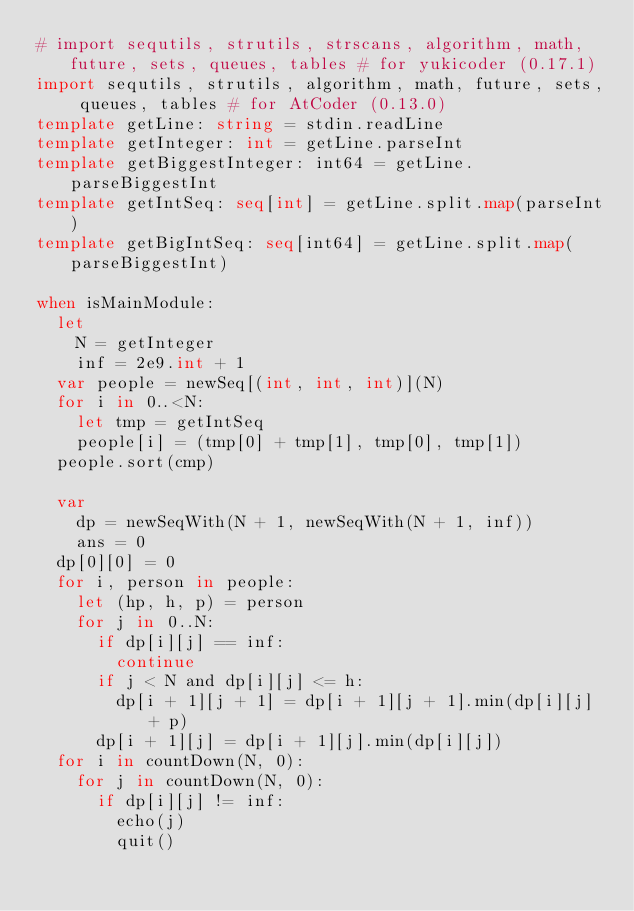Convert code to text. <code><loc_0><loc_0><loc_500><loc_500><_Nim_># import sequtils, strutils, strscans, algorithm, math, future, sets, queues, tables # for yukicoder (0.17.1)
import sequtils, strutils, algorithm, math, future, sets, queues, tables # for AtCoder (0.13.0)
template getLine: string = stdin.readLine
template getInteger: int = getLine.parseInt
template getBiggestInteger: int64 = getLine.parseBiggestInt
template getIntSeq: seq[int] = getLine.split.map(parseInt)
template getBigIntSeq: seq[int64] = getLine.split.map(parseBiggestInt)

when isMainModule:
  let
    N = getInteger
    inf = 2e9.int + 1
  var people = newSeq[(int, int, int)](N)
  for i in 0..<N:
    let tmp = getIntSeq
    people[i] = (tmp[0] + tmp[1], tmp[0], tmp[1])
  people.sort(cmp)

  var
    dp = newSeqWith(N + 1, newSeqWith(N + 1, inf))
    ans = 0
  dp[0][0] = 0
  for i, person in people:
    let (hp, h, p) = person
    for j in 0..N:
      if dp[i][j] == inf:
        continue
      if j < N and dp[i][j] <= h:
        dp[i + 1][j + 1] = dp[i + 1][j + 1].min(dp[i][j] + p)
      dp[i + 1][j] = dp[i + 1][j].min(dp[i][j])
  for i in countDown(N, 0):
    for j in countDown(N, 0):
      if dp[i][j] != inf:
        echo(j)
        quit()
</code> 